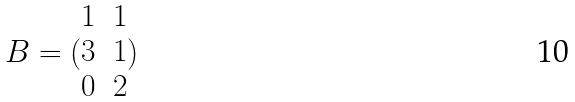Convert formula to latex. <formula><loc_0><loc_0><loc_500><loc_500>B = ( \begin{matrix} 1 & 1 \\ 3 & 1 \\ 0 & 2 \end{matrix} )</formula> 